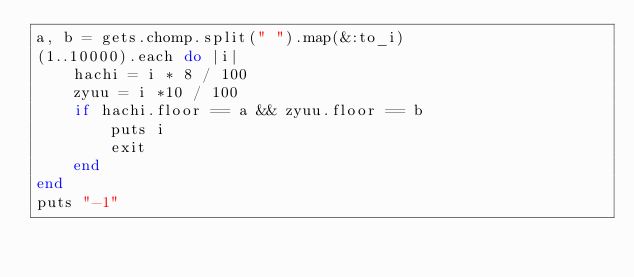<code> <loc_0><loc_0><loc_500><loc_500><_Ruby_>a, b = gets.chomp.split(" ").map(&:to_i)
(1..10000).each do |i|
    hachi = i * 8 / 100
    zyuu = i *10 / 100
    if hachi.floor == a && zyuu.floor == b
        puts i
        exit
    end
end
puts "-1"</code> 